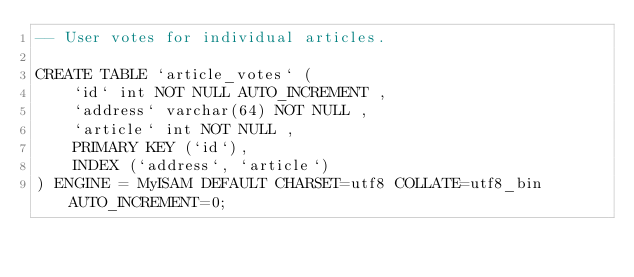<code> <loc_0><loc_0><loc_500><loc_500><_SQL_>-- User votes for individual articles.

CREATE TABLE `article_votes` (
	`id` int NOT NULL AUTO_INCREMENT ,
	`address` varchar(64) NOT NULL ,
	`article` int NOT NULL ,
	PRIMARY KEY (`id`),
	INDEX (`address`, `article`)
) ENGINE = MyISAM DEFAULT CHARSET=utf8 COLLATE=utf8_bin AUTO_INCREMENT=0;
</code> 